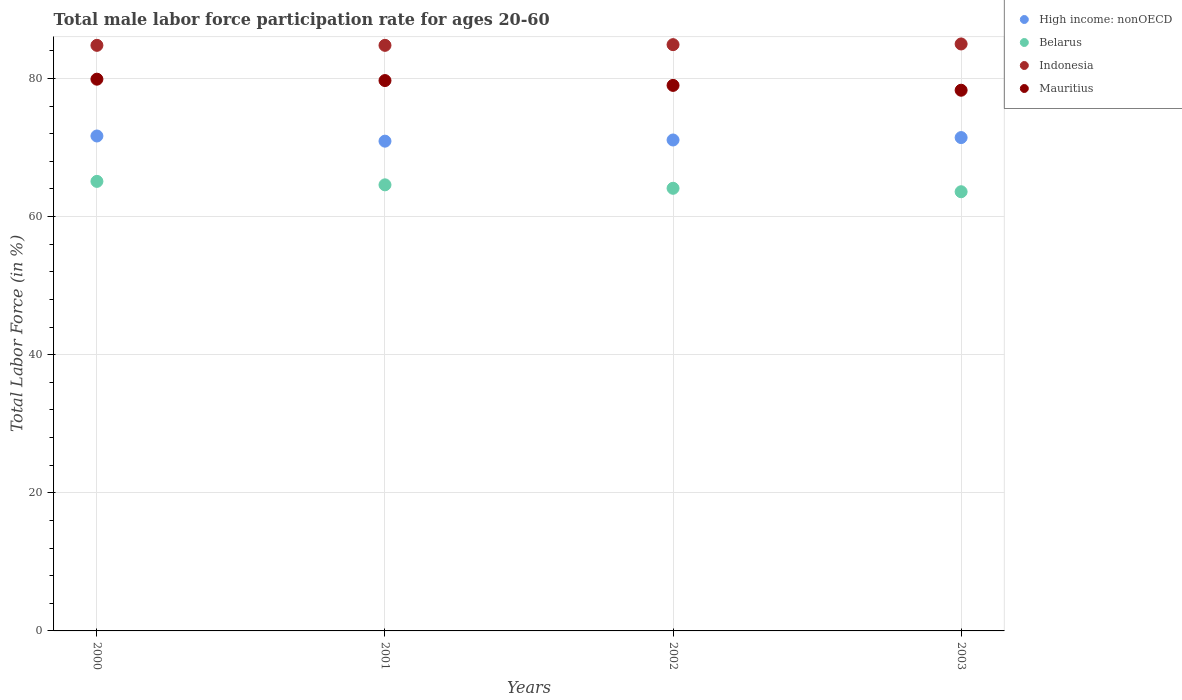How many different coloured dotlines are there?
Keep it short and to the point. 4. Is the number of dotlines equal to the number of legend labels?
Your answer should be very brief. Yes. What is the male labor force participation rate in Mauritius in 2003?
Your answer should be very brief. 78.3. Across all years, what is the maximum male labor force participation rate in Indonesia?
Your answer should be compact. 85. Across all years, what is the minimum male labor force participation rate in High income: nonOECD?
Your response must be concise. 70.92. What is the total male labor force participation rate in Indonesia in the graph?
Offer a terse response. 339.5. What is the difference between the male labor force participation rate in High income: nonOECD in 2000 and that in 2002?
Provide a succinct answer. 0.58. What is the difference between the male labor force participation rate in Belarus in 2003 and the male labor force participation rate in Indonesia in 2001?
Make the answer very short. -21.2. What is the average male labor force participation rate in Mauritius per year?
Your answer should be compact. 79.23. In the year 2003, what is the difference between the male labor force participation rate in Mauritius and male labor force participation rate in Indonesia?
Your response must be concise. -6.7. What is the ratio of the male labor force participation rate in High income: nonOECD in 2000 to that in 2002?
Keep it short and to the point. 1.01. Is the male labor force participation rate in Indonesia in 2001 less than that in 2002?
Ensure brevity in your answer.  Yes. Is the difference between the male labor force participation rate in Mauritius in 2000 and 2002 greater than the difference between the male labor force participation rate in Indonesia in 2000 and 2002?
Provide a succinct answer. Yes. What is the difference between the highest and the second highest male labor force participation rate in High income: nonOECD?
Provide a succinct answer. 0.23. What is the difference between the highest and the lowest male labor force participation rate in High income: nonOECD?
Provide a succinct answer. 0.75. Is it the case that in every year, the sum of the male labor force participation rate in Mauritius and male labor force participation rate in Belarus  is greater than the male labor force participation rate in High income: nonOECD?
Give a very brief answer. Yes. Is the male labor force participation rate in Belarus strictly less than the male labor force participation rate in Indonesia over the years?
Offer a very short reply. Yes. How many years are there in the graph?
Your response must be concise. 4. Are the values on the major ticks of Y-axis written in scientific E-notation?
Your response must be concise. No. Does the graph contain any zero values?
Give a very brief answer. No. Does the graph contain grids?
Your answer should be compact. Yes. How many legend labels are there?
Ensure brevity in your answer.  4. How are the legend labels stacked?
Your answer should be compact. Vertical. What is the title of the graph?
Offer a very short reply. Total male labor force participation rate for ages 20-60. What is the label or title of the Y-axis?
Offer a very short reply. Total Labor Force (in %). What is the Total Labor Force (in %) of High income: nonOECD in 2000?
Provide a succinct answer. 71.67. What is the Total Labor Force (in %) of Belarus in 2000?
Your response must be concise. 65.1. What is the Total Labor Force (in %) in Indonesia in 2000?
Ensure brevity in your answer.  84.8. What is the Total Labor Force (in %) of Mauritius in 2000?
Keep it short and to the point. 79.9. What is the Total Labor Force (in %) of High income: nonOECD in 2001?
Your answer should be very brief. 70.92. What is the Total Labor Force (in %) of Belarus in 2001?
Make the answer very short. 64.6. What is the Total Labor Force (in %) in Indonesia in 2001?
Your answer should be very brief. 84.8. What is the Total Labor Force (in %) in Mauritius in 2001?
Offer a terse response. 79.7. What is the Total Labor Force (in %) in High income: nonOECD in 2002?
Give a very brief answer. 71.09. What is the Total Labor Force (in %) of Belarus in 2002?
Offer a terse response. 64.1. What is the Total Labor Force (in %) in Indonesia in 2002?
Make the answer very short. 84.9. What is the Total Labor Force (in %) in Mauritius in 2002?
Your answer should be very brief. 79. What is the Total Labor Force (in %) in High income: nonOECD in 2003?
Offer a very short reply. 71.44. What is the Total Labor Force (in %) of Belarus in 2003?
Your answer should be very brief. 63.6. What is the Total Labor Force (in %) in Indonesia in 2003?
Offer a terse response. 85. What is the Total Labor Force (in %) in Mauritius in 2003?
Your answer should be very brief. 78.3. Across all years, what is the maximum Total Labor Force (in %) in High income: nonOECD?
Offer a terse response. 71.67. Across all years, what is the maximum Total Labor Force (in %) of Belarus?
Give a very brief answer. 65.1. Across all years, what is the maximum Total Labor Force (in %) in Indonesia?
Provide a succinct answer. 85. Across all years, what is the maximum Total Labor Force (in %) of Mauritius?
Your response must be concise. 79.9. Across all years, what is the minimum Total Labor Force (in %) in High income: nonOECD?
Offer a very short reply. 70.92. Across all years, what is the minimum Total Labor Force (in %) in Belarus?
Provide a succinct answer. 63.6. Across all years, what is the minimum Total Labor Force (in %) in Indonesia?
Offer a very short reply. 84.8. Across all years, what is the minimum Total Labor Force (in %) of Mauritius?
Keep it short and to the point. 78.3. What is the total Total Labor Force (in %) in High income: nonOECD in the graph?
Provide a succinct answer. 285.14. What is the total Total Labor Force (in %) of Belarus in the graph?
Give a very brief answer. 257.4. What is the total Total Labor Force (in %) in Indonesia in the graph?
Keep it short and to the point. 339.5. What is the total Total Labor Force (in %) in Mauritius in the graph?
Provide a succinct answer. 316.9. What is the difference between the Total Labor Force (in %) of High income: nonOECD in 2000 and that in 2001?
Provide a short and direct response. 0.75. What is the difference between the Total Labor Force (in %) in Belarus in 2000 and that in 2001?
Your answer should be very brief. 0.5. What is the difference between the Total Labor Force (in %) of Mauritius in 2000 and that in 2001?
Give a very brief answer. 0.2. What is the difference between the Total Labor Force (in %) of High income: nonOECD in 2000 and that in 2002?
Ensure brevity in your answer.  0.58. What is the difference between the Total Labor Force (in %) in Belarus in 2000 and that in 2002?
Your answer should be very brief. 1. What is the difference between the Total Labor Force (in %) of Indonesia in 2000 and that in 2002?
Make the answer very short. -0.1. What is the difference between the Total Labor Force (in %) of Mauritius in 2000 and that in 2002?
Your response must be concise. 0.9. What is the difference between the Total Labor Force (in %) in High income: nonOECD in 2000 and that in 2003?
Your answer should be very brief. 0.23. What is the difference between the Total Labor Force (in %) in Indonesia in 2000 and that in 2003?
Offer a terse response. -0.2. What is the difference between the Total Labor Force (in %) of Mauritius in 2000 and that in 2003?
Your answer should be very brief. 1.6. What is the difference between the Total Labor Force (in %) in High income: nonOECD in 2001 and that in 2002?
Make the answer very short. -0.17. What is the difference between the Total Labor Force (in %) of Mauritius in 2001 and that in 2002?
Offer a very short reply. 0.7. What is the difference between the Total Labor Force (in %) in High income: nonOECD in 2001 and that in 2003?
Your response must be concise. -0.52. What is the difference between the Total Labor Force (in %) in Belarus in 2001 and that in 2003?
Your answer should be very brief. 1. What is the difference between the Total Labor Force (in %) in Indonesia in 2001 and that in 2003?
Offer a very short reply. -0.2. What is the difference between the Total Labor Force (in %) of High income: nonOECD in 2002 and that in 2003?
Your response must be concise. -0.35. What is the difference between the Total Labor Force (in %) of Belarus in 2002 and that in 2003?
Offer a terse response. 0.5. What is the difference between the Total Labor Force (in %) in Indonesia in 2002 and that in 2003?
Provide a short and direct response. -0.1. What is the difference between the Total Labor Force (in %) of High income: nonOECD in 2000 and the Total Labor Force (in %) of Belarus in 2001?
Your answer should be very brief. 7.07. What is the difference between the Total Labor Force (in %) of High income: nonOECD in 2000 and the Total Labor Force (in %) of Indonesia in 2001?
Keep it short and to the point. -13.13. What is the difference between the Total Labor Force (in %) of High income: nonOECD in 2000 and the Total Labor Force (in %) of Mauritius in 2001?
Offer a terse response. -8.03. What is the difference between the Total Labor Force (in %) of Belarus in 2000 and the Total Labor Force (in %) of Indonesia in 2001?
Offer a terse response. -19.7. What is the difference between the Total Labor Force (in %) of Belarus in 2000 and the Total Labor Force (in %) of Mauritius in 2001?
Provide a short and direct response. -14.6. What is the difference between the Total Labor Force (in %) in High income: nonOECD in 2000 and the Total Labor Force (in %) in Belarus in 2002?
Give a very brief answer. 7.57. What is the difference between the Total Labor Force (in %) in High income: nonOECD in 2000 and the Total Labor Force (in %) in Indonesia in 2002?
Keep it short and to the point. -13.23. What is the difference between the Total Labor Force (in %) of High income: nonOECD in 2000 and the Total Labor Force (in %) of Mauritius in 2002?
Give a very brief answer. -7.33. What is the difference between the Total Labor Force (in %) of Belarus in 2000 and the Total Labor Force (in %) of Indonesia in 2002?
Your response must be concise. -19.8. What is the difference between the Total Labor Force (in %) of Belarus in 2000 and the Total Labor Force (in %) of Mauritius in 2002?
Keep it short and to the point. -13.9. What is the difference between the Total Labor Force (in %) in Indonesia in 2000 and the Total Labor Force (in %) in Mauritius in 2002?
Make the answer very short. 5.8. What is the difference between the Total Labor Force (in %) in High income: nonOECD in 2000 and the Total Labor Force (in %) in Belarus in 2003?
Your answer should be very brief. 8.07. What is the difference between the Total Labor Force (in %) in High income: nonOECD in 2000 and the Total Labor Force (in %) in Indonesia in 2003?
Provide a short and direct response. -13.33. What is the difference between the Total Labor Force (in %) of High income: nonOECD in 2000 and the Total Labor Force (in %) of Mauritius in 2003?
Keep it short and to the point. -6.63. What is the difference between the Total Labor Force (in %) in Belarus in 2000 and the Total Labor Force (in %) in Indonesia in 2003?
Offer a very short reply. -19.9. What is the difference between the Total Labor Force (in %) of Belarus in 2000 and the Total Labor Force (in %) of Mauritius in 2003?
Your response must be concise. -13.2. What is the difference between the Total Labor Force (in %) in High income: nonOECD in 2001 and the Total Labor Force (in %) in Belarus in 2002?
Provide a short and direct response. 6.82. What is the difference between the Total Labor Force (in %) in High income: nonOECD in 2001 and the Total Labor Force (in %) in Indonesia in 2002?
Give a very brief answer. -13.98. What is the difference between the Total Labor Force (in %) of High income: nonOECD in 2001 and the Total Labor Force (in %) of Mauritius in 2002?
Provide a short and direct response. -8.08. What is the difference between the Total Labor Force (in %) of Belarus in 2001 and the Total Labor Force (in %) of Indonesia in 2002?
Provide a short and direct response. -20.3. What is the difference between the Total Labor Force (in %) of Belarus in 2001 and the Total Labor Force (in %) of Mauritius in 2002?
Ensure brevity in your answer.  -14.4. What is the difference between the Total Labor Force (in %) of Indonesia in 2001 and the Total Labor Force (in %) of Mauritius in 2002?
Offer a very short reply. 5.8. What is the difference between the Total Labor Force (in %) in High income: nonOECD in 2001 and the Total Labor Force (in %) in Belarus in 2003?
Offer a very short reply. 7.32. What is the difference between the Total Labor Force (in %) in High income: nonOECD in 2001 and the Total Labor Force (in %) in Indonesia in 2003?
Keep it short and to the point. -14.08. What is the difference between the Total Labor Force (in %) of High income: nonOECD in 2001 and the Total Labor Force (in %) of Mauritius in 2003?
Make the answer very short. -7.38. What is the difference between the Total Labor Force (in %) of Belarus in 2001 and the Total Labor Force (in %) of Indonesia in 2003?
Ensure brevity in your answer.  -20.4. What is the difference between the Total Labor Force (in %) of Belarus in 2001 and the Total Labor Force (in %) of Mauritius in 2003?
Ensure brevity in your answer.  -13.7. What is the difference between the Total Labor Force (in %) of Indonesia in 2001 and the Total Labor Force (in %) of Mauritius in 2003?
Offer a terse response. 6.5. What is the difference between the Total Labor Force (in %) in High income: nonOECD in 2002 and the Total Labor Force (in %) in Belarus in 2003?
Your answer should be very brief. 7.49. What is the difference between the Total Labor Force (in %) of High income: nonOECD in 2002 and the Total Labor Force (in %) of Indonesia in 2003?
Your answer should be very brief. -13.91. What is the difference between the Total Labor Force (in %) in High income: nonOECD in 2002 and the Total Labor Force (in %) in Mauritius in 2003?
Offer a terse response. -7.21. What is the difference between the Total Labor Force (in %) in Belarus in 2002 and the Total Labor Force (in %) in Indonesia in 2003?
Give a very brief answer. -20.9. What is the difference between the Total Labor Force (in %) in Belarus in 2002 and the Total Labor Force (in %) in Mauritius in 2003?
Ensure brevity in your answer.  -14.2. What is the difference between the Total Labor Force (in %) in Indonesia in 2002 and the Total Labor Force (in %) in Mauritius in 2003?
Offer a terse response. 6.6. What is the average Total Labor Force (in %) of High income: nonOECD per year?
Your response must be concise. 71.28. What is the average Total Labor Force (in %) of Belarus per year?
Give a very brief answer. 64.35. What is the average Total Labor Force (in %) of Indonesia per year?
Your answer should be very brief. 84.88. What is the average Total Labor Force (in %) of Mauritius per year?
Keep it short and to the point. 79.22. In the year 2000, what is the difference between the Total Labor Force (in %) in High income: nonOECD and Total Labor Force (in %) in Belarus?
Offer a very short reply. 6.57. In the year 2000, what is the difference between the Total Labor Force (in %) of High income: nonOECD and Total Labor Force (in %) of Indonesia?
Ensure brevity in your answer.  -13.13. In the year 2000, what is the difference between the Total Labor Force (in %) of High income: nonOECD and Total Labor Force (in %) of Mauritius?
Ensure brevity in your answer.  -8.23. In the year 2000, what is the difference between the Total Labor Force (in %) in Belarus and Total Labor Force (in %) in Indonesia?
Offer a terse response. -19.7. In the year 2000, what is the difference between the Total Labor Force (in %) in Belarus and Total Labor Force (in %) in Mauritius?
Your answer should be compact. -14.8. In the year 2000, what is the difference between the Total Labor Force (in %) in Indonesia and Total Labor Force (in %) in Mauritius?
Offer a very short reply. 4.9. In the year 2001, what is the difference between the Total Labor Force (in %) in High income: nonOECD and Total Labor Force (in %) in Belarus?
Provide a short and direct response. 6.32. In the year 2001, what is the difference between the Total Labor Force (in %) in High income: nonOECD and Total Labor Force (in %) in Indonesia?
Your answer should be very brief. -13.88. In the year 2001, what is the difference between the Total Labor Force (in %) of High income: nonOECD and Total Labor Force (in %) of Mauritius?
Your response must be concise. -8.78. In the year 2001, what is the difference between the Total Labor Force (in %) of Belarus and Total Labor Force (in %) of Indonesia?
Provide a succinct answer. -20.2. In the year 2001, what is the difference between the Total Labor Force (in %) in Belarus and Total Labor Force (in %) in Mauritius?
Ensure brevity in your answer.  -15.1. In the year 2002, what is the difference between the Total Labor Force (in %) in High income: nonOECD and Total Labor Force (in %) in Belarus?
Provide a short and direct response. 6.99. In the year 2002, what is the difference between the Total Labor Force (in %) of High income: nonOECD and Total Labor Force (in %) of Indonesia?
Ensure brevity in your answer.  -13.81. In the year 2002, what is the difference between the Total Labor Force (in %) of High income: nonOECD and Total Labor Force (in %) of Mauritius?
Your answer should be very brief. -7.91. In the year 2002, what is the difference between the Total Labor Force (in %) of Belarus and Total Labor Force (in %) of Indonesia?
Give a very brief answer. -20.8. In the year 2002, what is the difference between the Total Labor Force (in %) of Belarus and Total Labor Force (in %) of Mauritius?
Offer a very short reply. -14.9. In the year 2002, what is the difference between the Total Labor Force (in %) in Indonesia and Total Labor Force (in %) in Mauritius?
Make the answer very short. 5.9. In the year 2003, what is the difference between the Total Labor Force (in %) in High income: nonOECD and Total Labor Force (in %) in Belarus?
Your response must be concise. 7.84. In the year 2003, what is the difference between the Total Labor Force (in %) of High income: nonOECD and Total Labor Force (in %) of Indonesia?
Your answer should be very brief. -13.56. In the year 2003, what is the difference between the Total Labor Force (in %) of High income: nonOECD and Total Labor Force (in %) of Mauritius?
Your answer should be compact. -6.86. In the year 2003, what is the difference between the Total Labor Force (in %) of Belarus and Total Labor Force (in %) of Indonesia?
Give a very brief answer. -21.4. In the year 2003, what is the difference between the Total Labor Force (in %) of Belarus and Total Labor Force (in %) of Mauritius?
Your response must be concise. -14.7. What is the ratio of the Total Labor Force (in %) of High income: nonOECD in 2000 to that in 2001?
Keep it short and to the point. 1.01. What is the ratio of the Total Labor Force (in %) in Belarus in 2000 to that in 2001?
Your response must be concise. 1.01. What is the ratio of the Total Labor Force (in %) of Indonesia in 2000 to that in 2001?
Your response must be concise. 1. What is the ratio of the Total Labor Force (in %) in High income: nonOECD in 2000 to that in 2002?
Ensure brevity in your answer.  1.01. What is the ratio of the Total Labor Force (in %) of Belarus in 2000 to that in 2002?
Your answer should be very brief. 1.02. What is the ratio of the Total Labor Force (in %) in Indonesia in 2000 to that in 2002?
Make the answer very short. 1. What is the ratio of the Total Labor Force (in %) of Mauritius in 2000 to that in 2002?
Keep it short and to the point. 1.01. What is the ratio of the Total Labor Force (in %) in Belarus in 2000 to that in 2003?
Give a very brief answer. 1.02. What is the ratio of the Total Labor Force (in %) in Indonesia in 2000 to that in 2003?
Your response must be concise. 1. What is the ratio of the Total Labor Force (in %) of Mauritius in 2000 to that in 2003?
Your answer should be very brief. 1.02. What is the ratio of the Total Labor Force (in %) of Indonesia in 2001 to that in 2002?
Keep it short and to the point. 1. What is the ratio of the Total Labor Force (in %) of Mauritius in 2001 to that in 2002?
Provide a succinct answer. 1.01. What is the ratio of the Total Labor Force (in %) in Belarus in 2001 to that in 2003?
Give a very brief answer. 1.02. What is the ratio of the Total Labor Force (in %) in Indonesia in 2001 to that in 2003?
Keep it short and to the point. 1. What is the ratio of the Total Labor Force (in %) in Mauritius in 2001 to that in 2003?
Your answer should be compact. 1.02. What is the ratio of the Total Labor Force (in %) in High income: nonOECD in 2002 to that in 2003?
Make the answer very short. 1. What is the ratio of the Total Labor Force (in %) in Belarus in 2002 to that in 2003?
Provide a succinct answer. 1.01. What is the ratio of the Total Labor Force (in %) of Indonesia in 2002 to that in 2003?
Your response must be concise. 1. What is the ratio of the Total Labor Force (in %) of Mauritius in 2002 to that in 2003?
Give a very brief answer. 1.01. What is the difference between the highest and the second highest Total Labor Force (in %) of High income: nonOECD?
Make the answer very short. 0.23. What is the difference between the highest and the lowest Total Labor Force (in %) in High income: nonOECD?
Give a very brief answer. 0.75. What is the difference between the highest and the lowest Total Labor Force (in %) of Belarus?
Your response must be concise. 1.5. What is the difference between the highest and the lowest Total Labor Force (in %) of Indonesia?
Your answer should be very brief. 0.2. What is the difference between the highest and the lowest Total Labor Force (in %) in Mauritius?
Provide a short and direct response. 1.6. 